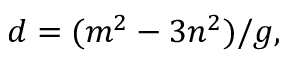Convert formula to latex. <formula><loc_0><loc_0><loc_500><loc_500>d = ( m ^ { 2 } - 3 n ^ { 2 } ) / g ,</formula> 